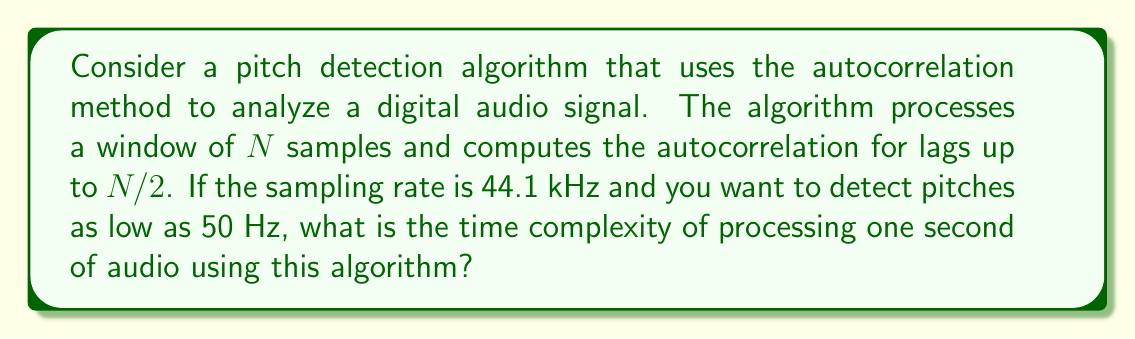Give your solution to this math problem. To solve this problem, we need to follow these steps:

1. Calculate the window size $N$:
   - For a 50 Hz pitch, the period is $1/50 = 0.02$ seconds
   - At 44.1 kHz sampling rate, $N = 0.02 \times 44100 = 882$ samples

2. Determine the number of windows in one second:
   - One second contains $44100$ samples
   - Number of windows = $44100 / 882 \approx 50$

3. Analyze the complexity of processing one window:
   - The autocorrelation is computed for lags up to $N/2$
   - For each lag, we need to compute the sum of products for $N$ terms
   - This results in a complexity of $O(N^2)$ for one window

4. Calculate the total complexity for one second:
   - We process approximately 50 windows
   - Each window has a complexity of $O(N^2)$
   - Total complexity: $50 \times O(N^2) = O(50N^2)$

5. Substitute the value of $N$:
   - $N = 882$
   - Complexity = $O(50 \times 882^2) = O(38,808,200)$

Therefore, the time complexity for processing one second of audio is $O(N^2)$, where $N$ is the window size, or more specifically, $O(38,808,200)$ operations.
Answer: $O(N^2)$, where $N$ is the window size, or approximately $O(38,808,200)$ operations per second of audio. 